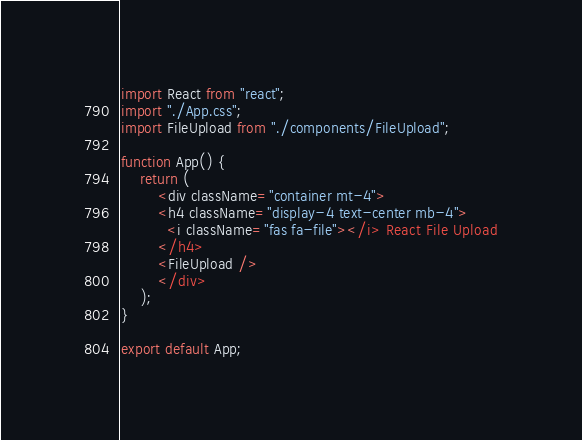<code> <loc_0><loc_0><loc_500><loc_500><_JavaScript_>import React from "react";
import "./App.css";
import FileUpload from "./components/FileUpload";

function App() {
    return (
        <div className="container mt-4">
        <h4 className="display-4 text-center mb-4">
          <i className="fas fa-file"></i> React File Upload
        </h4>
        <FileUpload />
        </div>
    );
}

export default App;
</code> 